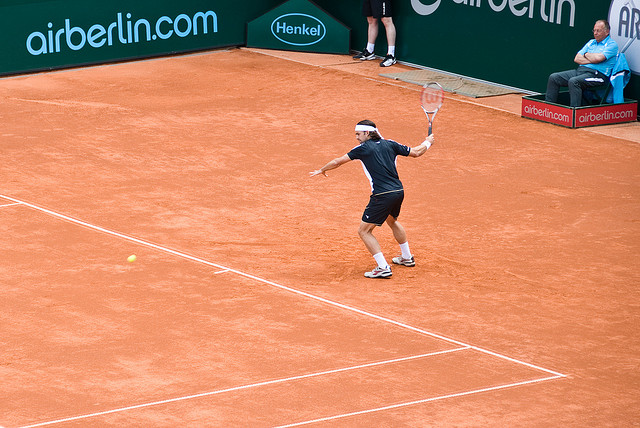Identify the text displayed in this image. airberline.com Henkel airberlin.com AIRBERLIN.COM AR 3 